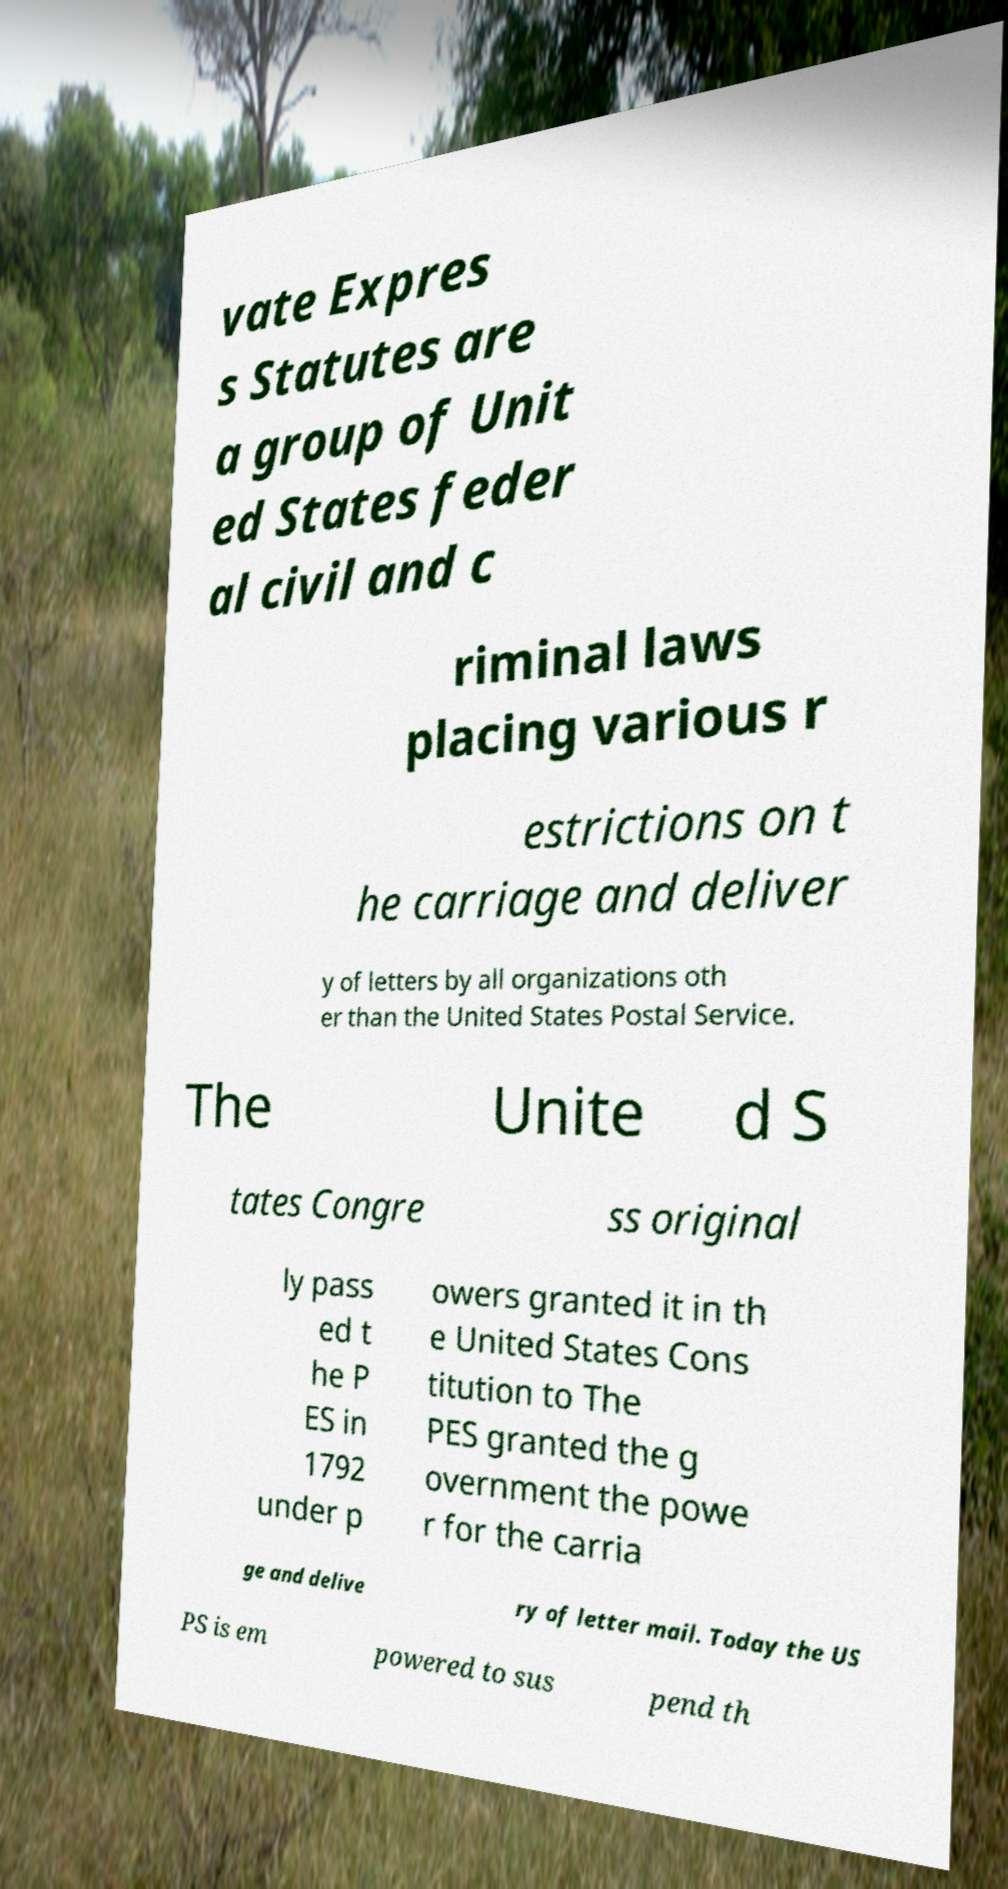Could you assist in decoding the text presented in this image and type it out clearly? vate Expres s Statutes are a group of Unit ed States feder al civil and c riminal laws placing various r estrictions on t he carriage and deliver y of letters by all organizations oth er than the United States Postal Service. The Unite d S tates Congre ss original ly pass ed t he P ES in 1792 under p owers granted it in th e United States Cons titution to The PES granted the g overnment the powe r for the carria ge and delive ry of letter mail. Today the US PS is em powered to sus pend th 